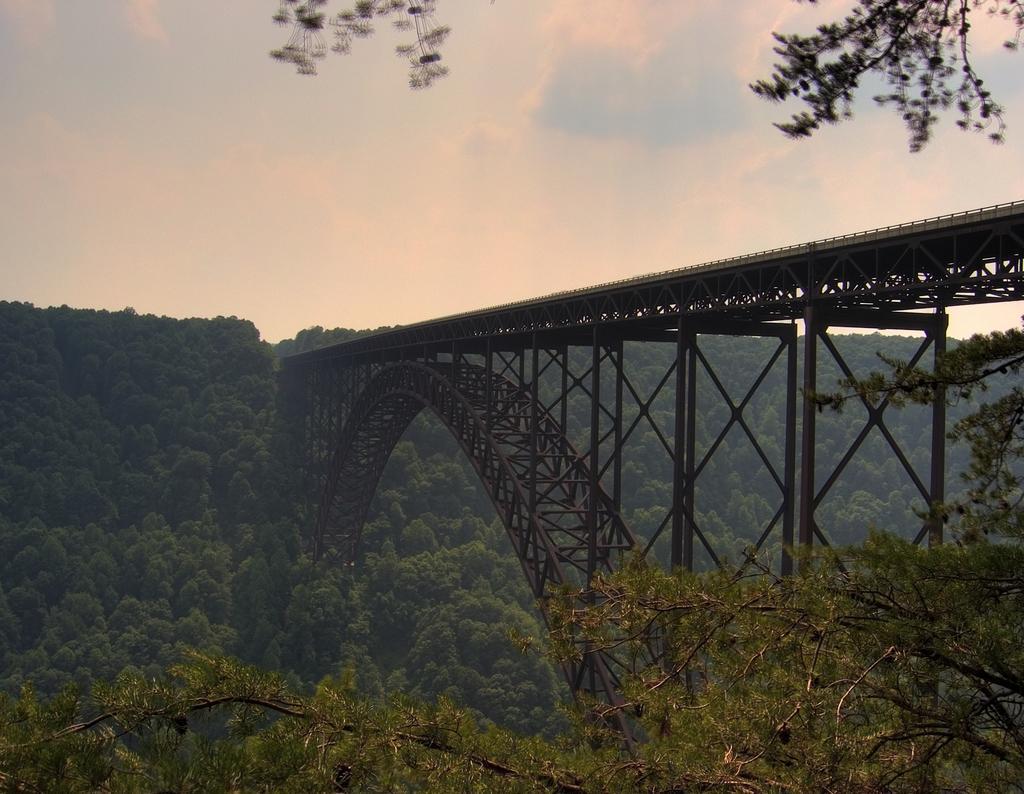Describe this image in one or two sentences. In this image I can see a bridge which is in black and brown color. I can see trees. The sky is in blue and white color. 